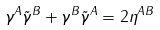<formula> <loc_0><loc_0><loc_500><loc_500>\gamma ^ { A } \tilde { \gamma } ^ { B } + \gamma ^ { B } \tilde { \gamma } ^ { A } = 2 \eta ^ { A B }</formula> 